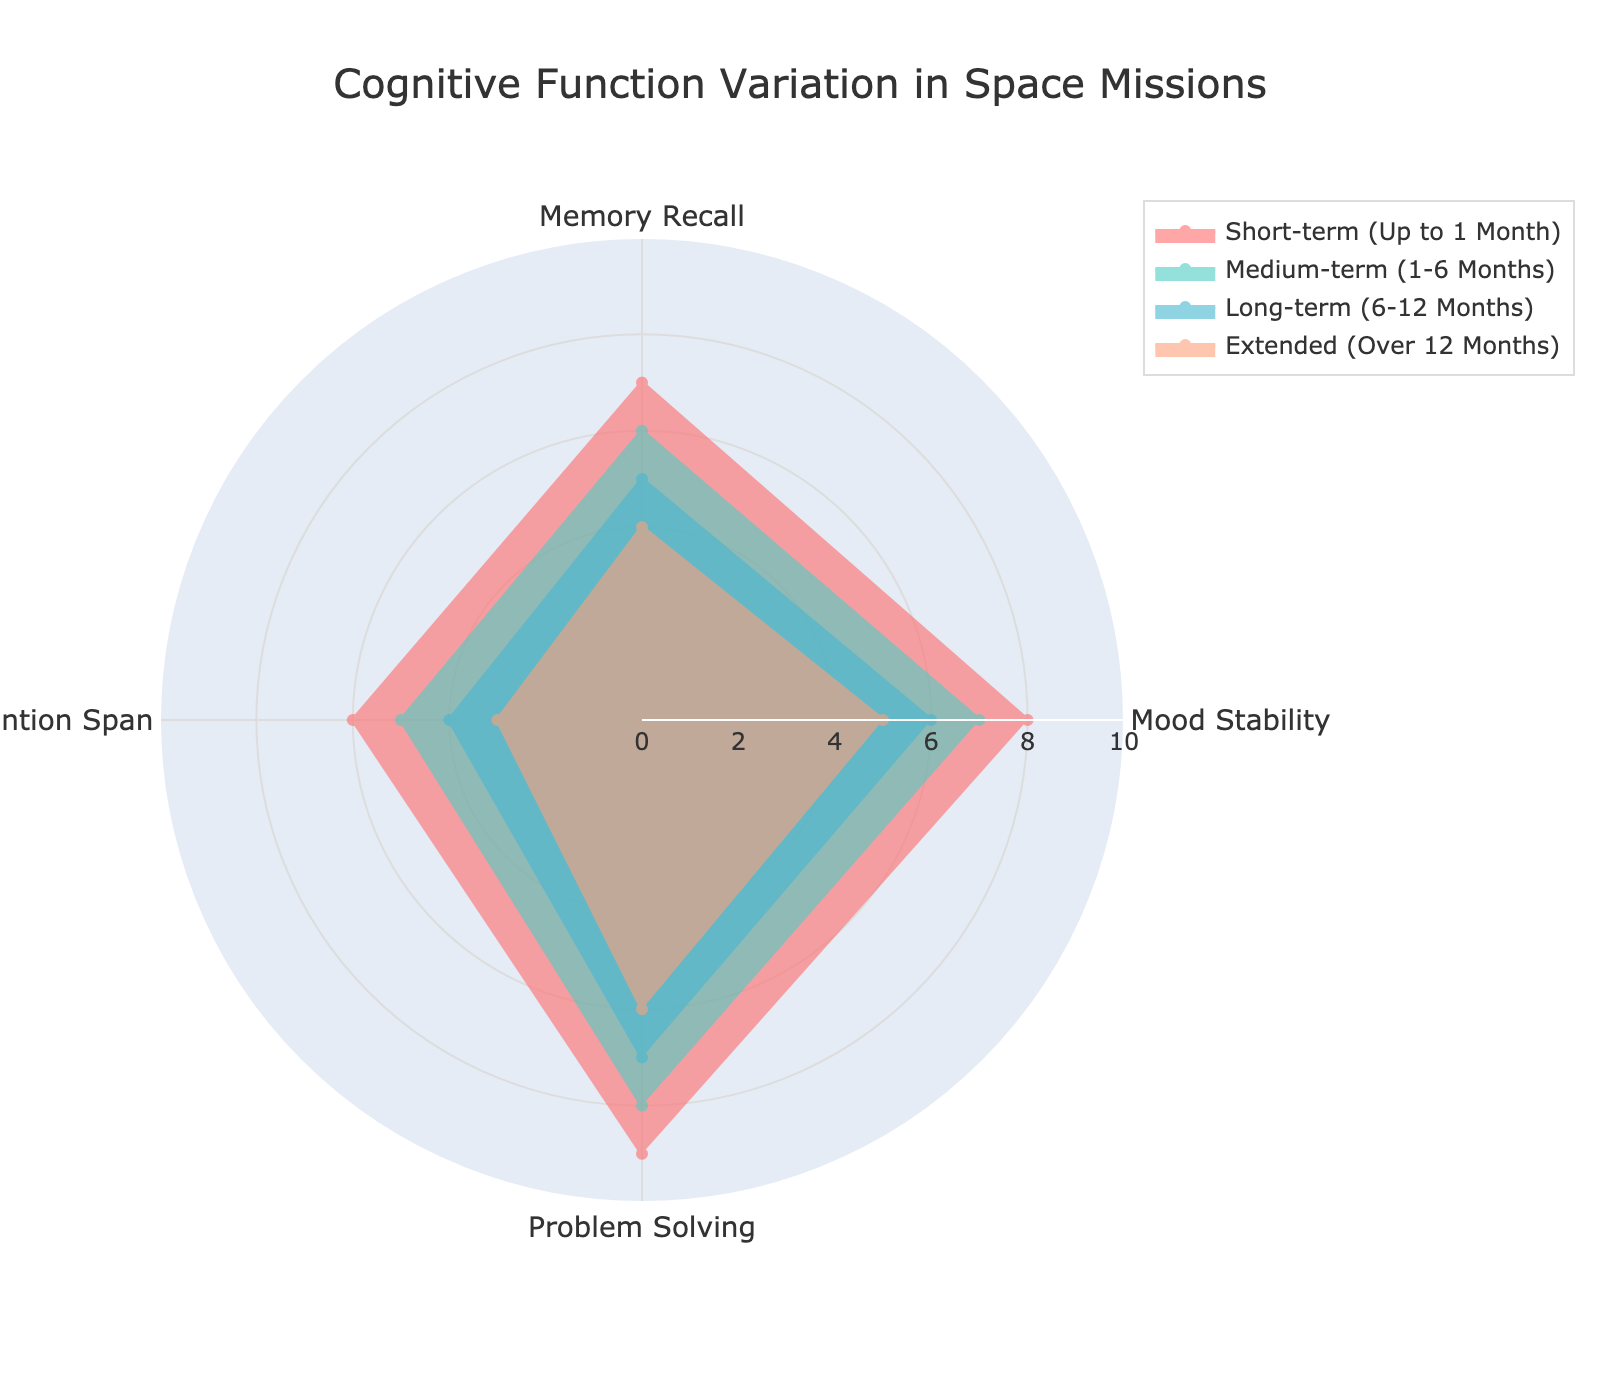What is the highest Mood Stability score for different mission durations? The radar chart shows various scores for different mission durations. Identify the Mood Stability score for each group and locate the highest value.
Answer: 8 Which cognitive function has the lowest score for long-term missions (6-12 months)? Look at the radar chart and focus on the scores for long-term missions. Identify the cognitive function with the lowest score within this group.
Answer: Attention Span How does Problem Solving ability change from short-term to extended missions? Observe the Problem Solving scores for short-term and extended missions on the radar chart. Compare the values to understand the change.
Answer: Decreases from 9 to 6 Out of Memory Recall and Attention Span, which cognitive function shows a greater decline from short-term to medium-term missions? Compare the changes in scores for Memory Recall and Attention Span from short-term to medium-term missions. Subtract the medium-term score from the short-term score for both functions and identify which has the greater decline.
Answer: Attention Span What are the average scores of cognitive functions for medium-term missions? Calculate the average score for medium-term missions by summing all cognitive function scores and dividing by the number of functions (4).
Answer: 6.5 Which mission duration has the highest average cognitive function score? Calculate the average score for each mission duration by summing their cognitive function scores and dividing by the number of functions (4). Identify the one with the highest average.
Answer: Short-term Is there any cognitive function that decreases consistently across all mission durations? Check the radar chart for each cognitive function across all mission durations and see if any function's score consistently decreases.
Answer: Yes, Attention Span How does Mood Stability vary across different mission durations? Analyze the Mood Stability scores across all mission durations on the radar chart, noting any increase or decrease.
Answer: Decreases from 8 to 5 